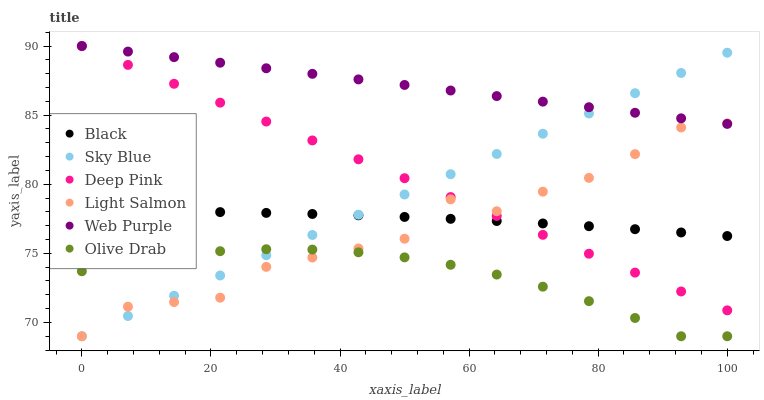Does Olive Drab have the minimum area under the curve?
Answer yes or no. Yes. Does Web Purple have the maximum area under the curve?
Answer yes or no. Yes. Does Deep Pink have the minimum area under the curve?
Answer yes or no. No. Does Deep Pink have the maximum area under the curve?
Answer yes or no. No. Is Sky Blue the smoothest?
Answer yes or no. Yes. Is Light Salmon the roughest?
Answer yes or no. Yes. Is Deep Pink the smoothest?
Answer yes or no. No. Is Deep Pink the roughest?
Answer yes or no. No. Does Light Salmon have the lowest value?
Answer yes or no. Yes. Does Deep Pink have the lowest value?
Answer yes or no. No. Does Web Purple have the highest value?
Answer yes or no. Yes. Does Black have the highest value?
Answer yes or no. No. Is Black less than Web Purple?
Answer yes or no. Yes. Is Web Purple greater than Olive Drab?
Answer yes or no. Yes. Does Web Purple intersect Sky Blue?
Answer yes or no. Yes. Is Web Purple less than Sky Blue?
Answer yes or no. No. Is Web Purple greater than Sky Blue?
Answer yes or no. No. Does Black intersect Web Purple?
Answer yes or no. No. 